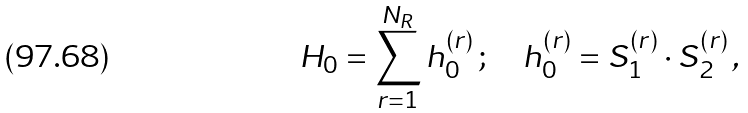Convert formula to latex. <formula><loc_0><loc_0><loc_500><loc_500>H _ { 0 } = \sum _ { r = 1 } ^ { N _ { R } } h _ { 0 } ^ { ( r ) } \, ; \quad h _ { 0 } ^ { ( r ) } = { S } _ { 1 } ^ { ( r ) } \cdot { S } _ { 2 } ^ { ( r ) } \, ,</formula> 